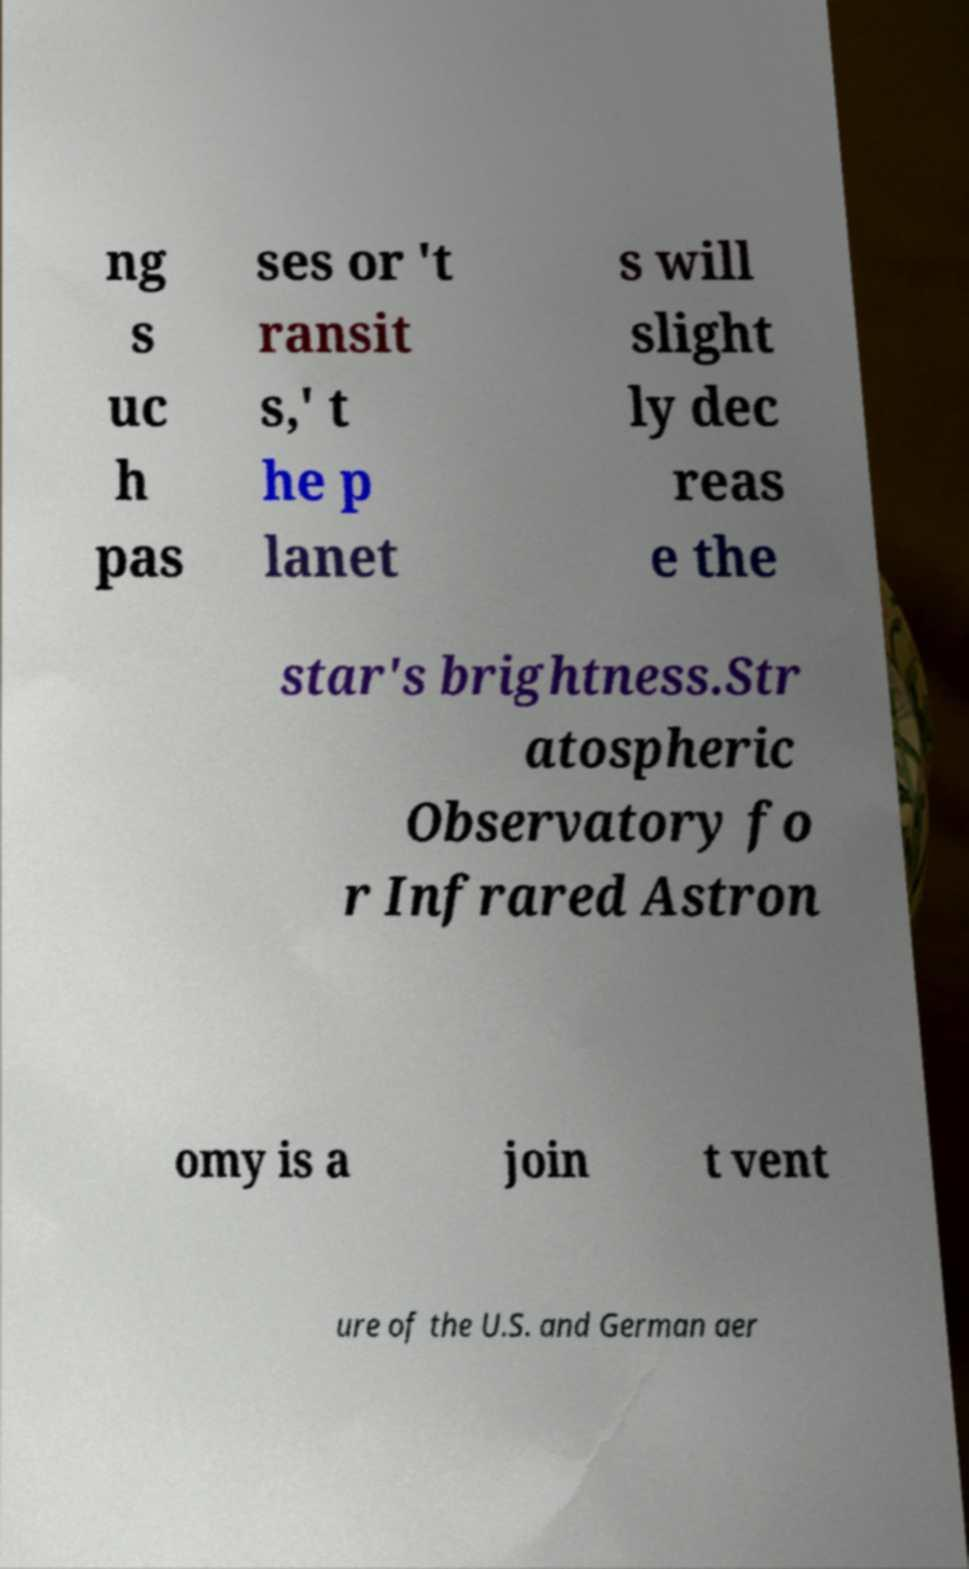There's text embedded in this image that I need extracted. Can you transcribe it verbatim? ng s uc h pas ses or 't ransit s,' t he p lanet s will slight ly dec reas e the star's brightness.Str atospheric Observatory fo r Infrared Astron omy is a join t vent ure of the U.S. and German aer 